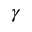<formula> <loc_0><loc_0><loc_500><loc_500>\gamma</formula> 